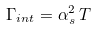<formula> <loc_0><loc_0><loc_500><loc_500>\Gamma _ { i n t } = \alpha _ { s } ^ { 2 } \, T</formula> 